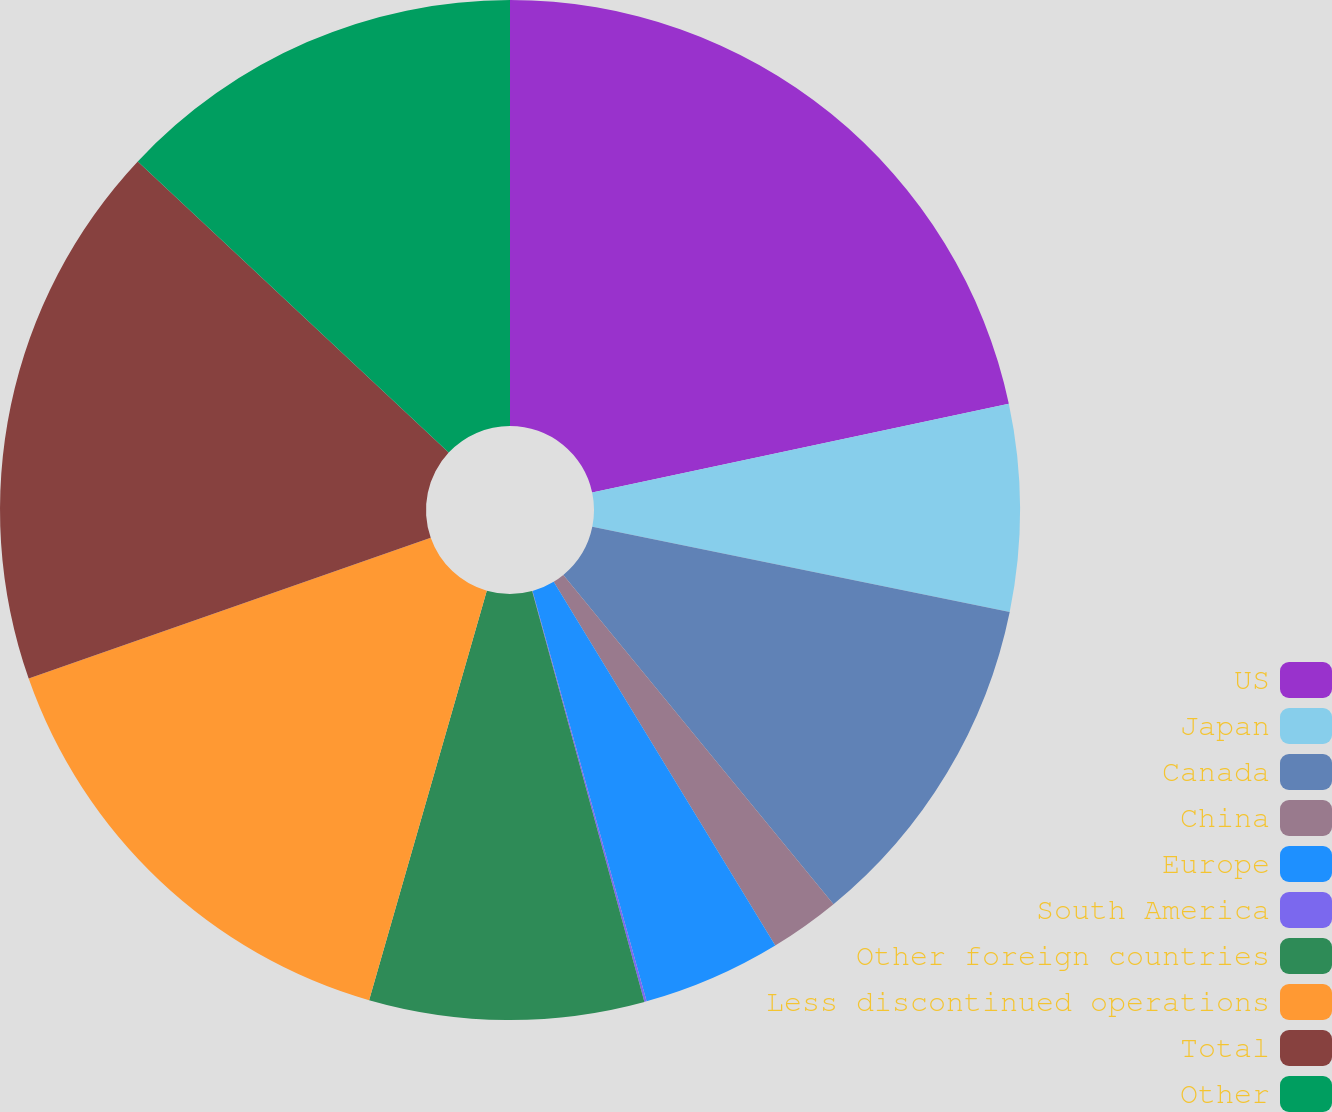Convert chart. <chart><loc_0><loc_0><loc_500><loc_500><pie_chart><fcel>US<fcel>Japan<fcel>Canada<fcel>China<fcel>Europe<fcel>South America<fcel>Other foreign countries<fcel>Less discontinued operations<fcel>Total<fcel>Other<nl><fcel>21.66%<fcel>6.54%<fcel>10.86%<fcel>2.23%<fcel>4.39%<fcel>0.07%<fcel>8.7%<fcel>15.18%<fcel>17.34%<fcel>13.02%<nl></chart> 